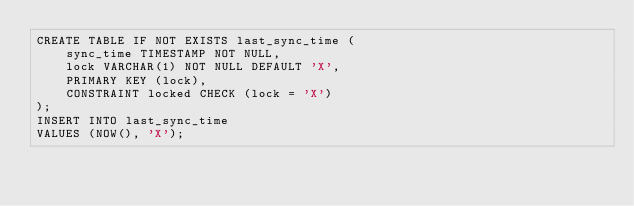Convert code to text. <code><loc_0><loc_0><loc_500><loc_500><_SQL_>CREATE TABLE IF NOT EXISTS last_sync_time (
    sync_time TIMESTAMP NOT NULL,
    lock VARCHAR(1) NOT NULL DEFAULT 'X',
    PRIMARY KEY (lock),
    CONSTRAINT locked CHECK (lock = 'X')
);
INSERT INTO last_sync_time
VALUES (NOW(), 'X');</code> 